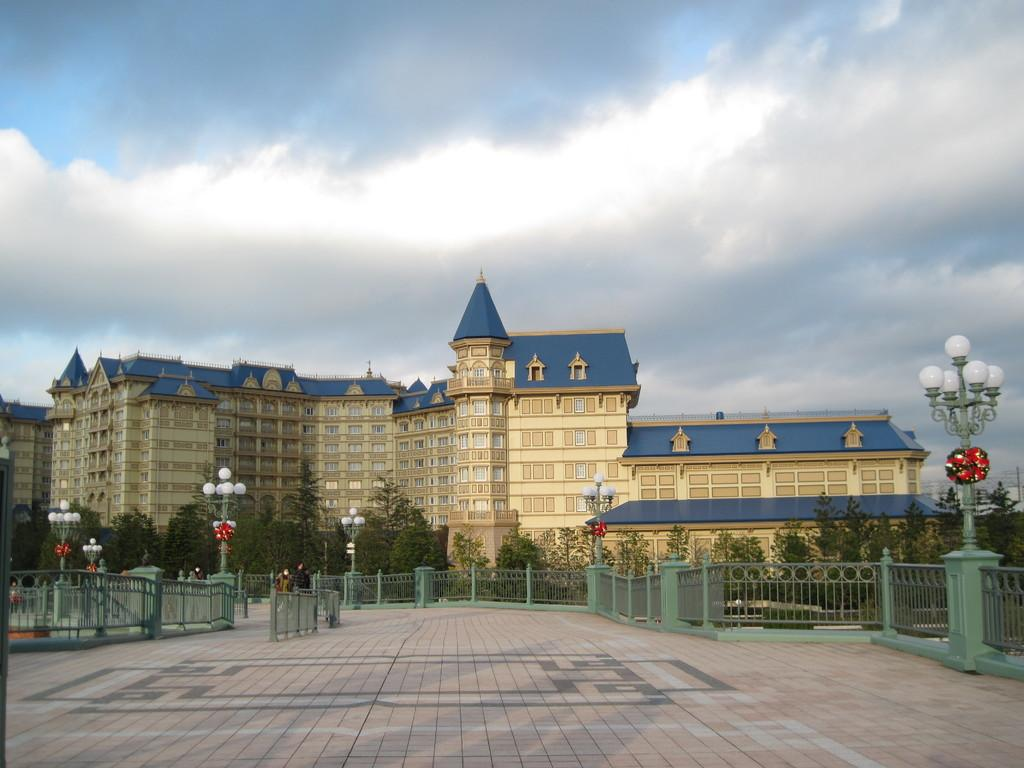What can be seen in the image that might be used for support or safety? There is a railing in the image that might be used for support or safety. What can be seen in the image that provides illumination? There are lights in the image that provide illumination. What can be seen in the background of the image that indicates the presence of vegetation? There are trees in the background of the image that indicate the presence of vegetation. What can be seen in the background of the image that indicates the presence of human-made structures? There are buildings in the background of the image that indicate the presence of human-made structures. What can be seen in the sky in the background of the image? There are clouds in the sky in the background of the image. What type of stew is being prepared in the image? There is no stew present in the image; it features a railing, lights, trees, buildings, and clouds. How does the image stop the flow of traffic? The image does not depict any traffic or roadways, so it cannot stop the flow of traffic. 